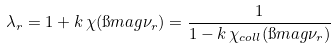<formula> <loc_0><loc_0><loc_500><loc_500>\lambda _ { r } = 1 + k \, \chi ( \i m a g \nu _ { r } ) = \frac { 1 } { 1 - k \, \chi _ { c o l l } ( \i m a g \nu _ { r } ) }</formula> 